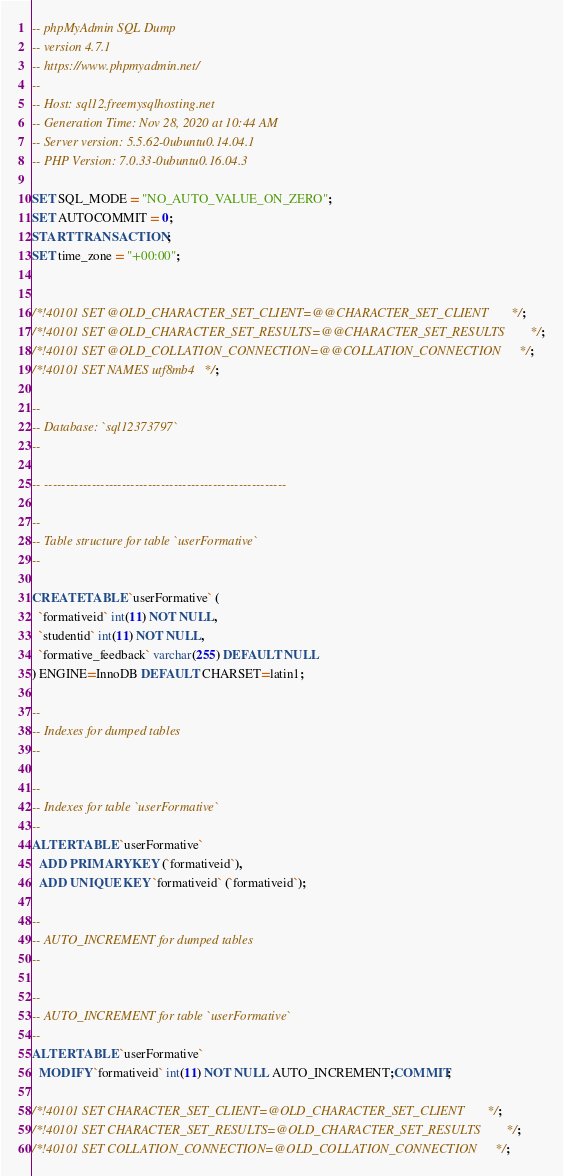Convert code to text. <code><loc_0><loc_0><loc_500><loc_500><_SQL_>-- phpMyAdmin SQL Dump
-- version 4.7.1
-- https://www.phpmyadmin.net/
--
-- Host: sql12.freemysqlhosting.net
-- Generation Time: Nov 28, 2020 at 10:44 AM
-- Server version: 5.5.62-0ubuntu0.14.04.1
-- PHP Version: 7.0.33-0ubuntu0.16.04.3

SET SQL_MODE = "NO_AUTO_VALUE_ON_ZERO";
SET AUTOCOMMIT = 0;
START TRANSACTION;
SET time_zone = "+00:00";


/*!40101 SET @OLD_CHARACTER_SET_CLIENT=@@CHARACTER_SET_CLIENT */;
/*!40101 SET @OLD_CHARACTER_SET_RESULTS=@@CHARACTER_SET_RESULTS */;
/*!40101 SET @OLD_COLLATION_CONNECTION=@@COLLATION_CONNECTION */;
/*!40101 SET NAMES utf8mb4 */;

--
-- Database: `sql12373797`
--

-- --------------------------------------------------------

--
-- Table structure for table `userFormative`
--

CREATE TABLE `userFormative` (
  `formativeid` int(11) NOT NULL,
  `studentid` int(11) NOT NULL,
  `formative_feedback` varchar(255) DEFAULT NULL
) ENGINE=InnoDB DEFAULT CHARSET=latin1;

--
-- Indexes for dumped tables
--

--
-- Indexes for table `userFormative`
--
ALTER TABLE `userFormative`
  ADD PRIMARY KEY (`formativeid`),
  ADD UNIQUE KEY `formativeid` (`formativeid`);

--
-- AUTO_INCREMENT for dumped tables
--

--
-- AUTO_INCREMENT for table `userFormative`
--
ALTER TABLE `userFormative`
  MODIFY `formativeid` int(11) NOT NULL AUTO_INCREMENT;COMMIT;

/*!40101 SET CHARACTER_SET_CLIENT=@OLD_CHARACTER_SET_CLIENT */;
/*!40101 SET CHARACTER_SET_RESULTS=@OLD_CHARACTER_SET_RESULTS */;
/*!40101 SET COLLATION_CONNECTION=@OLD_COLLATION_CONNECTION */;
</code> 